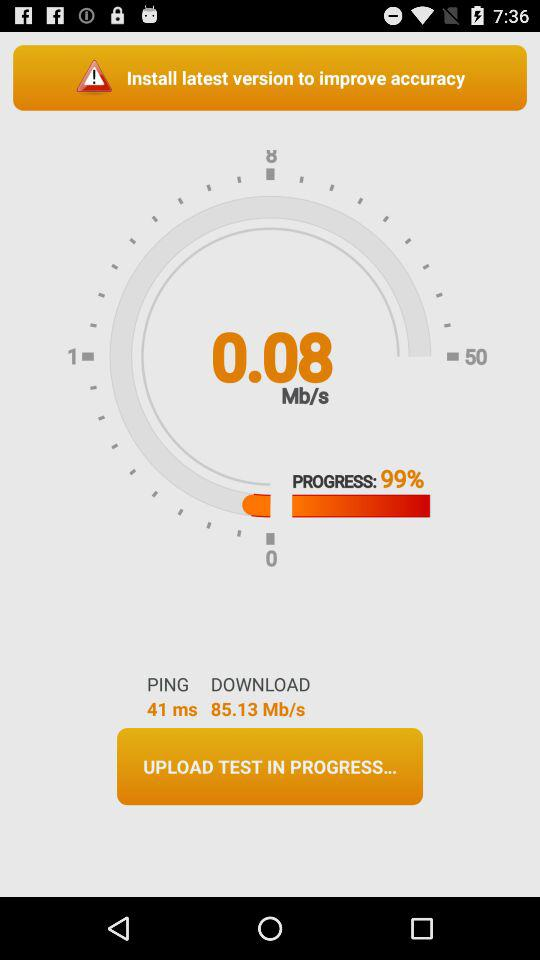What's the progress percentage? The progress percentage is 99%. 